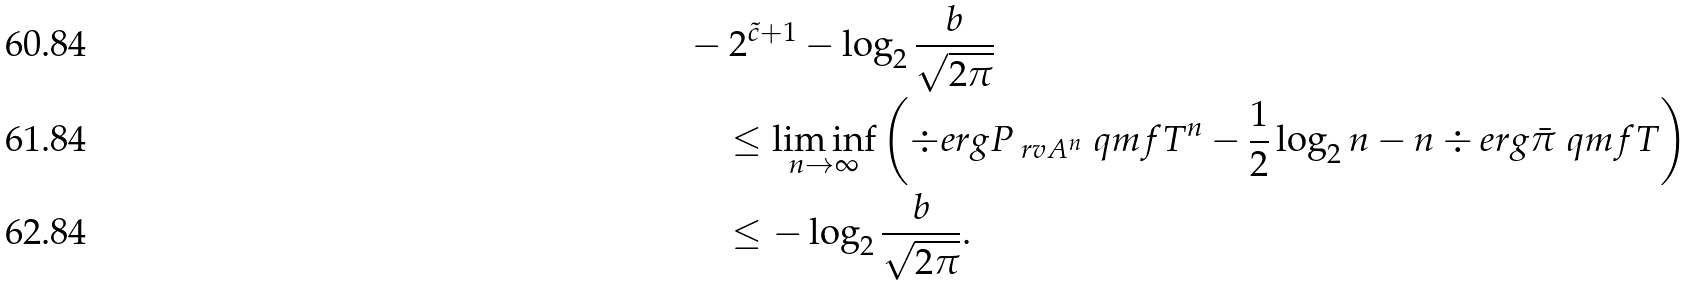<formula> <loc_0><loc_0><loc_500><loc_500>& - 2 ^ { \tilde { c } + 1 } - \log _ { 2 } \frac { b } { \sqrt { 2 \pi } } \\ & \quad \leq \liminf _ { n \to \infty } \left ( \div e r g { P _ { \ r v { A } ^ { n } } } { \ q m f { T } ^ { n } } - \frac { 1 } { 2 } \log _ { 2 } n - n \div e r g { \bar { \pi } } { \ q m f { T } } \right ) \\ & \quad \leq - \log _ { 2 } \frac { b } { \sqrt { 2 \pi } } .</formula> 